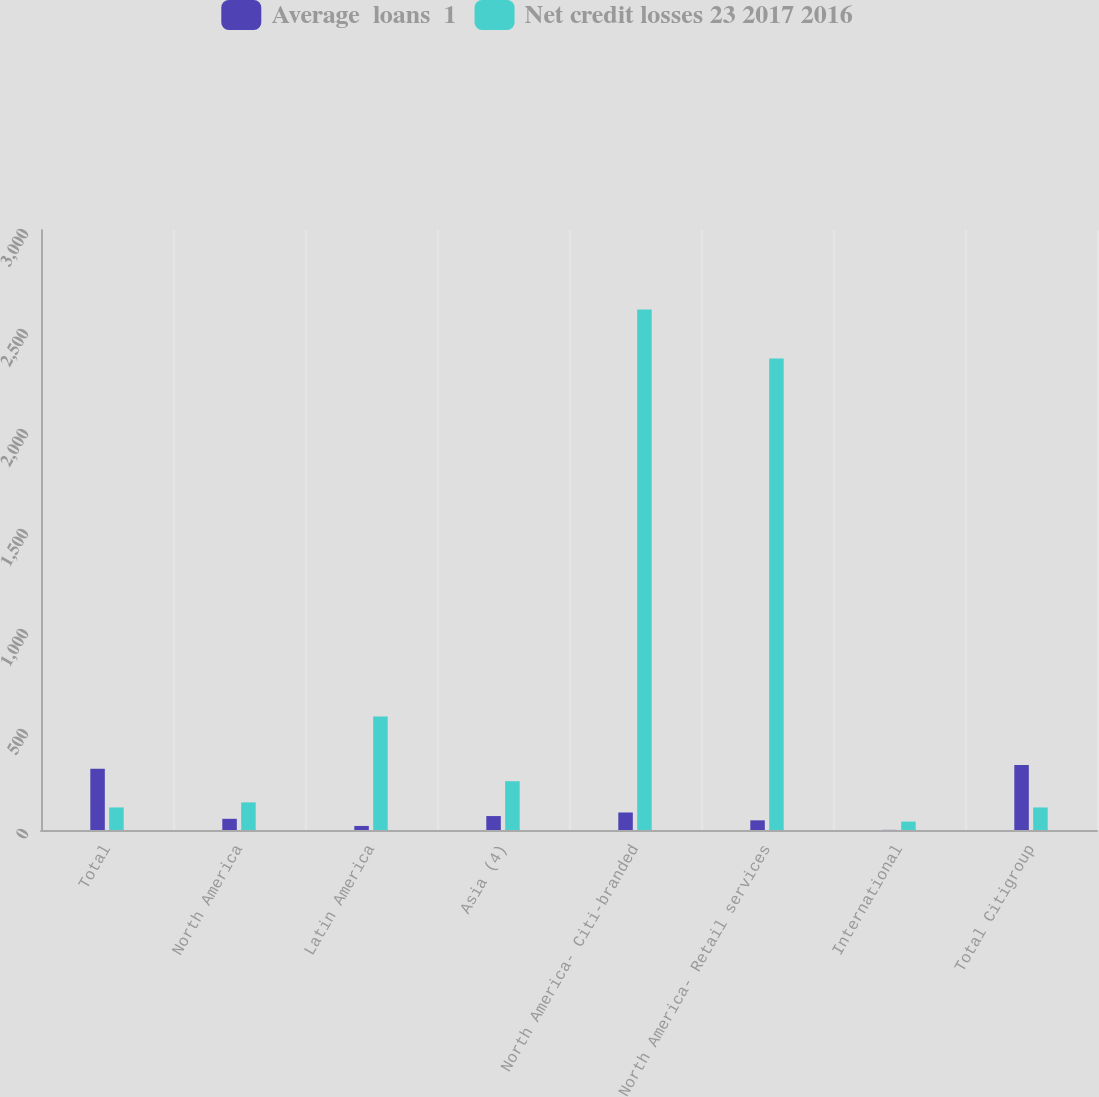Convert chart. <chart><loc_0><loc_0><loc_500><loc_500><stacked_bar_chart><ecel><fcel>Total<fcel>North America<fcel>Latin America<fcel>Asia (4)<fcel>North America- Citi-branded<fcel>North America- Retail services<fcel>International<fcel>Total Citigroup<nl><fcel>Average  loans  1<fcel>306.2<fcel>56<fcel>20.3<fcel>69.7<fcel>87.5<fcel>48.3<fcel>0.7<fcel>324.9<nl><fcel>Net credit losses 23 2017 2016<fcel>112.75<fcel>138<fcel>567<fcel>244<fcel>2602<fcel>2357<fcel>42<fcel>112.75<nl></chart> 